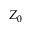Convert formula to latex. <formula><loc_0><loc_0><loc_500><loc_500>Z _ { 0 }</formula> 